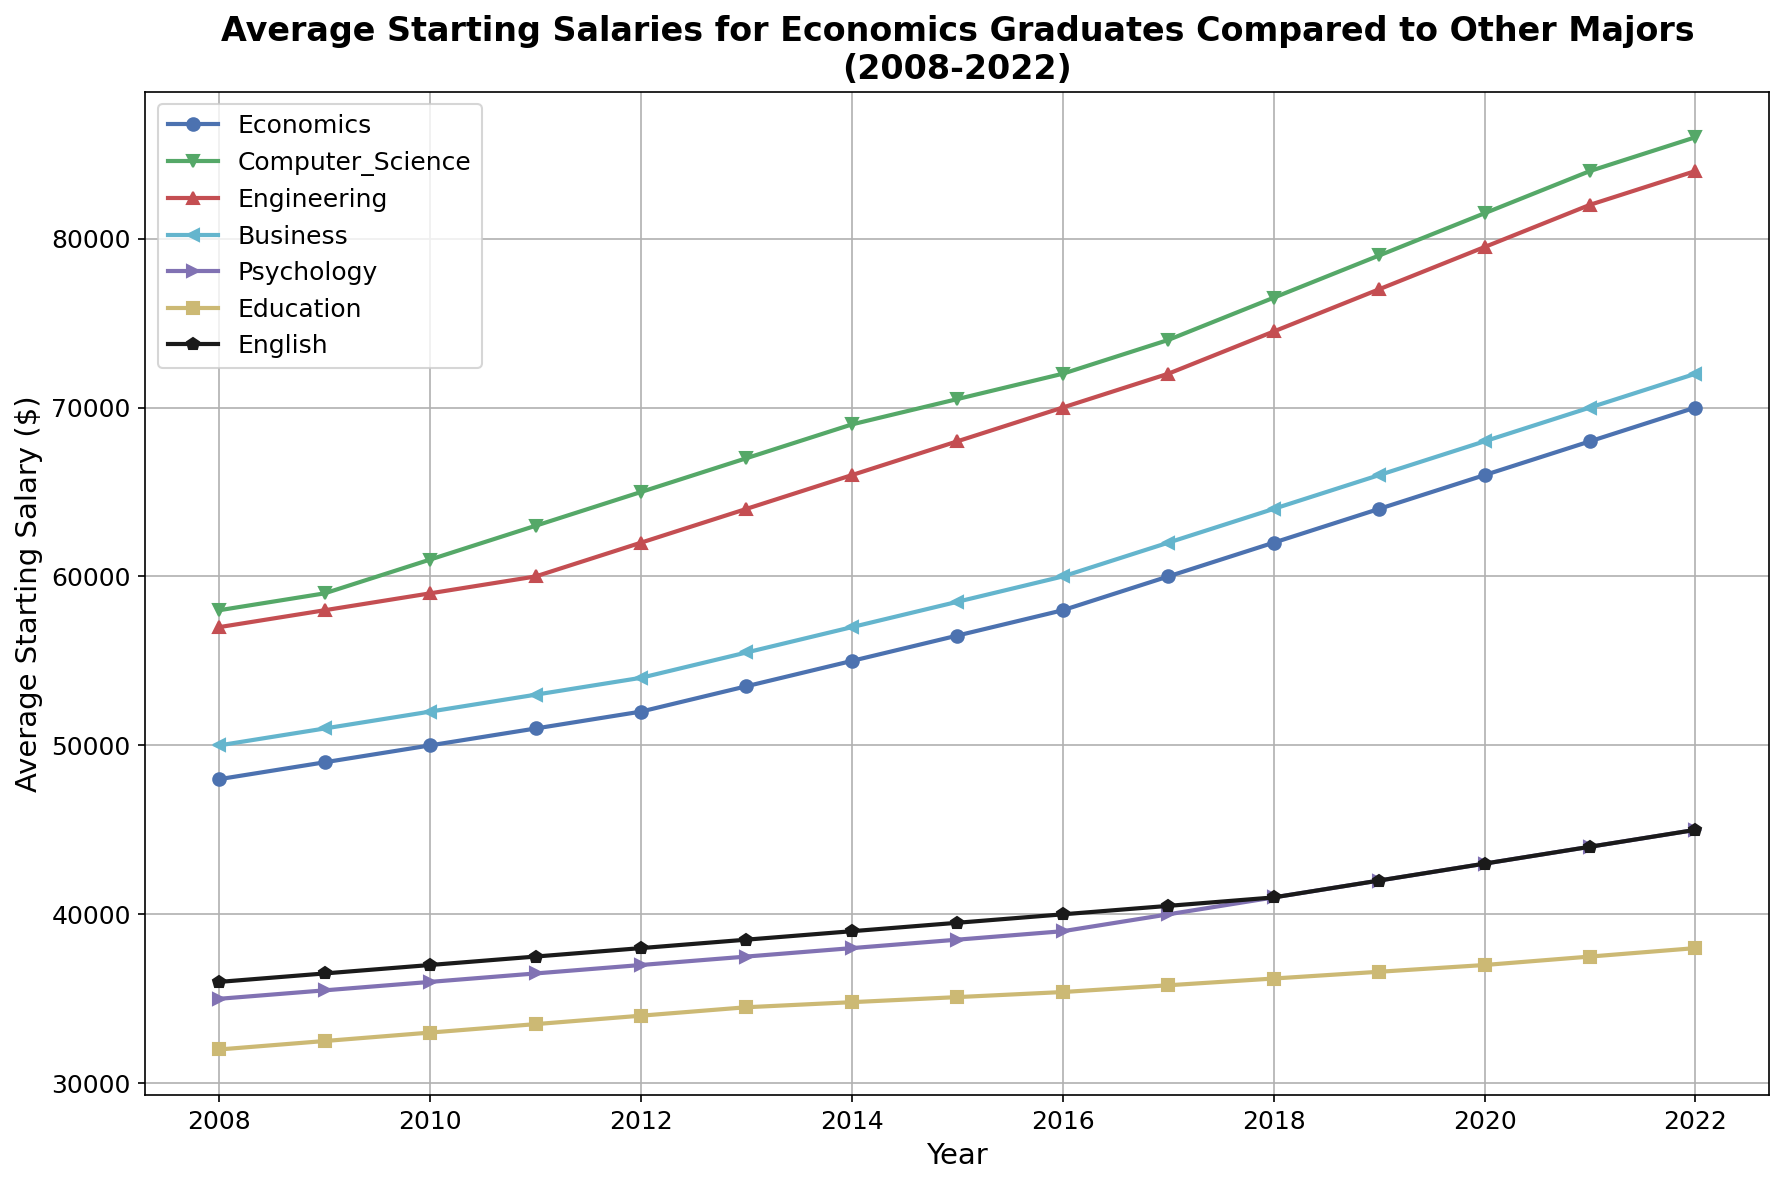What is the average starting salary for Economics graduates in 2022? Check the salary value for Economics graduates in 2022 from the figure and read the y-axis label. The salary for Economics graduates in 2022 is shown in blue and sits at the point where the curve meets the vertical line at 2022.
Answer: $70,000 How did the starting salary for Business majors change from 2008 to 2022? Locate the starting salary for Business majors in 2008 and 2022 on the y-axis. Subtract the 2008 value from the 2022 value. The respective values are $50,000 and $72,000. So, the difference is $72,000 - $50,000.
Answer: $22,000 Which major saw the highest average starting salary in 2022? Identify which line reaches the highest point in the year 2022. The line for Computer Science, marked in green, reaches the highest intersection point for that year.
Answer: Computer Science Which major had the lowest average starting salary in 2018? Find the point in the year 2018 where the y-value is the lowest. The Education major, shown in yellow, has the lowest salary value of $36,200 in 2018.
Answer: Education Between Economics and Engineering, which major experienced a greater increase in average starting salary from 2008 to 2022? Calculate the increase for both majors from 2008 to 2022. For Economics: $70,000 (2022) - $48,000 (2008) = $22,000. For Engineering: $84,000 (2022) - $57,000 (2008) = $27,000. Compare the results.
Answer: Engineering By how much did the average starting salary for Psychology majors increase from 2015 to 2021? Subtract the starting salary in 2015 from that in 2021 for Psychology majors. The respective values are $38,500 (2021) - $38,500 (2015).
Answer: $6,500 In which years did the starting salary for Engineering majors exceed $70,000? Find the years on the x-axis where the y-values for Engineering majors are above $70,000. This value is surpassed starting from the year 2014 onwards.
Answer: 2014-2022 What is the difference between the average starting salary for English majors and Psychology majors in 2022? Look at the salaries for English majors ($45,000) and Psychology majors ($45,000) in 2022 and calculate the difference.
Answer: $0 Which major showed the most consistent increase in average starting salaries over the 15 years? Identify the major whose line is the smoothest and shows a consistent upward trend without fluctuations. The Economics major, shown in blue, exhibits this pattern.
Answer: Economics In what year did Computer Science graduates see the highest jump in average starting salary? Look for the year where the slope of the Computer Science line (green) is steepest. The jump appears most prominently between 2020 and 2021.
Answer: 2021 